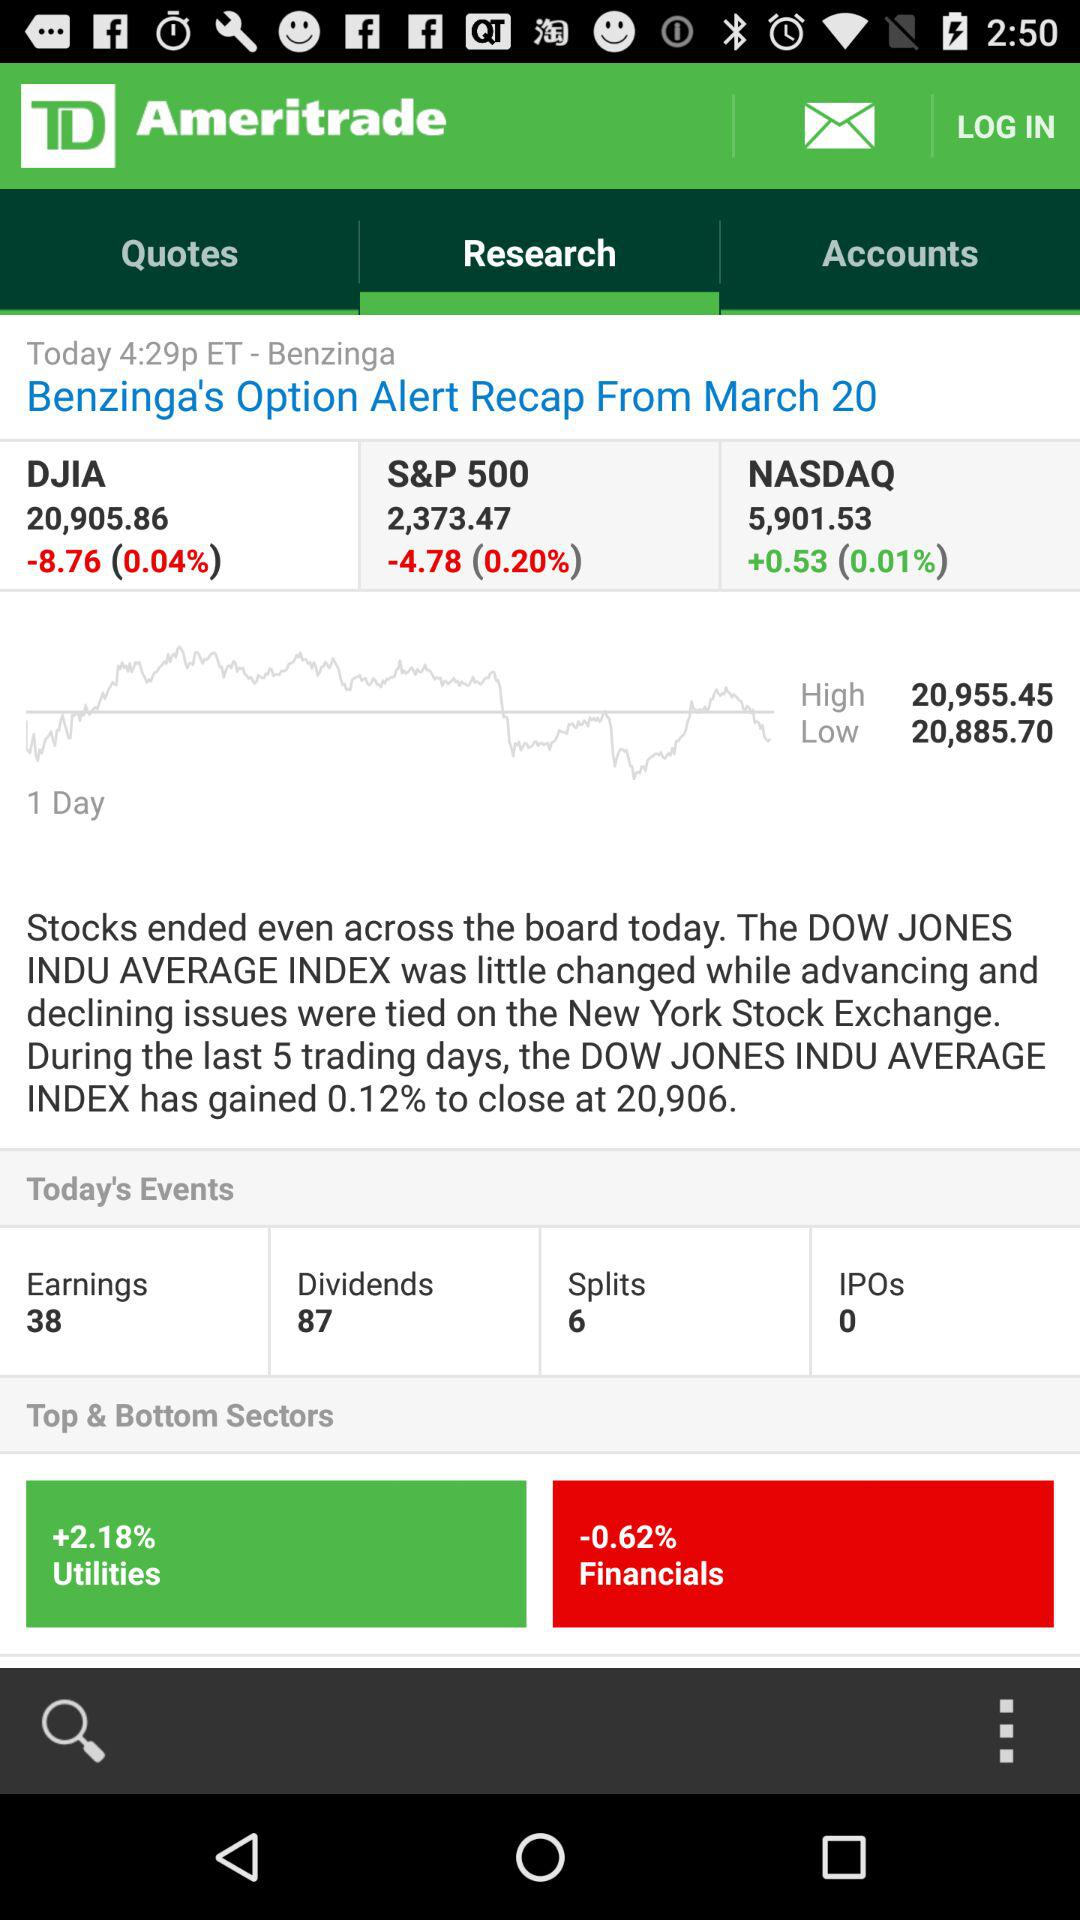What is the percentage of utilities? The percentage is +2.18. 